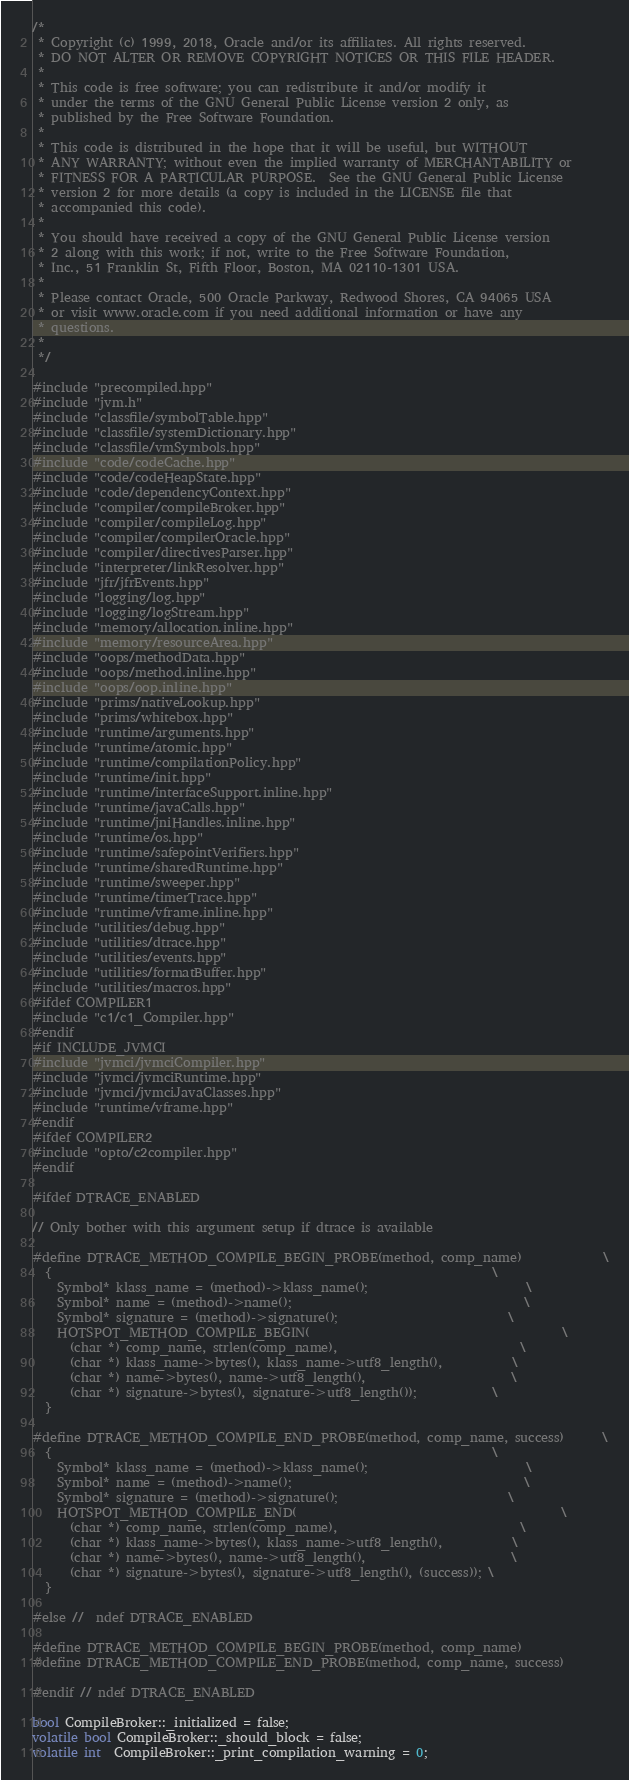Convert code to text. <code><loc_0><loc_0><loc_500><loc_500><_C++_>/*
 * Copyright (c) 1999, 2018, Oracle and/or its affiliates. All rights reserved.
 * DO NOT ALTER OR REMOVE COPYRIGHT NOTICES OR THIS FILE HEADER.
 *
 * This code is free software; you can redistribute it and/or modify it
 * under the terms of the GNU General Public License version 2 only, as
 * published by the Free Software Foundation.
 *
 * This code is distributed in the hope that it will be useful, but WITHOUT
 * ANY WARRANTY; without even the implied warranty of MERCHANTABILITY or
 * FITNESS FOR A PARTICULAR PURPOSE.  See the GNU General Public License
 * version 2 for more details (a copy is included in the LICENSE file that
 * accompanied this code).
 *
 * You should have received a copy of the GNU General Public License version
 * 2 along with this work; if not, write to the Free Software Foundation,
 * Inc., 51 Franklin St, Fifth Floor, Boston, MA 02110-1301 USA.
 *
 * Please contact Oracle, 500 Oracle Parkway, Redwood Shores, CA 94065 USA
 * or visit www.oracle.com if you need additional information or have any
 * questions.
 *
 */

#include "precompiled.hpp"
#include "jvm.h"
#include "classfile/symbolTable.hpp"
#include "classfile/systemDictionary.hpp"
#include "classfile/vmSymbols.hpp"
#include "code/codeCache.hpp"
#include "code/codeHeapState.hpp"
#include "code/dependencyContext.hpp"
#include "compiler/compileBroker.hpp"
#include "compiler/compileLog.hpp"
#include "compiler/compilerOracle.hpp"
#include "compiler/directivesParser.hpp"
#include "interpreter/linkResolver.hpp"
#include "jfr/jfrEvents.hpp"
#include "logging/log.hpp"
#include "logging/logStream.hpp"
#include "memory/allocation.inline.hpp"
#include "memory/resourceArea.hpp"
#include "oops/methodData.hpp"
#include "oops/method.inline.hpp"
#include "oops/oop.inline.hpp"
#include "prims/nativeLookup.hpp"
#include "prims/whitebox.hpp"
#include "runtime/arguments.hpp"
#include "runtime/atomic.hpp"
#include "runtime/compilationPolicy.hpp"
#include "runtime/init.hpp"
#include "runtime/interfaceSupport.inline.hpp"
#include "runtime/javaCalls.hpp"
#include "runtime/jniHandles.inline.hpp"
#include "runtime/os.hpp"
#include "runtime/safepointVerifiers.hpp"
#include "runtime/sharedRuntime.hpp"
#include "runtime/sweeper.hpp"
#include "runtime/timerTrace.hpp"
#include "runtime/vframe.inline.hpp"
#include "utilities/debug.hpp"
#include "utilities/dtrace.hpp"
#include "utilities/events.hpp"
#include "utilities/formatBuffer.hpp"
#include "utilities/macros.hpp"
#ifdef COMPILER1
#include "c1/c1_Compiler.hpp"
#endif
#if INCLUDE_JVMCI
#include "jvmci/jvmciCompiler.hpp"
#include "jvmci/jvmciRuntime.hpp"
#include "jvmci/jvmciJavaClasses.hpp"
#include "runtime/vframe.hpp"
#endif
#ifdef COMPILER2
#include "opto/c2compiler.hpp"
#endif

#ifdef DTRACE_ENABLED

// Only bother with this argument setup if dtrace is available

#define DTRACE_METHOD_COMPILE_BEGIN_PROBE(method, comp_name)             \
  {                                                                      \
    Symbol* klass_name = (method)->klass_name();                         \
    Symbol* name = (method)->name();                                     \
    Symbol* signature = (method)->signature();                           \
    HOTSPOT_METHOD_COMPILE_BEGIN(                                        \
      (char *) comp_name, strlen(comp_name),                             \
      (char *) klass_name->bytes(), klass_name->utf8_length(),           \
      (char *) name->bytes(), name->utf8_length(),                       \
      (char *) signature->bytes(), signature->utf8_length());            \
  }

#define DTRACE_METHOD_COMPILE_END_PROBE(method, comp_name, success)      \
  {                                                                      \
    Symbol* klass_name = (method)->klass_name();                         \
    Symbol* name = (method)->name();                                     \
    Symbol* signature = (method)->signature();                           \
    HOTSPOT_METHOD_COMPILE_END(                                          \
      (char *) comp_name, strlen(comp_name),                             \
      (char *) klass_name->bytes(), klass_name->utf8_length(),           \
      (char *) name->bytes(), name->utf8_length(),                       \
      (char *) signature->bytes(), signature->utf8_length(), (success)); \
  }

#else //  ndef DTRACE_ENABLED

#define DTRACE_METHOD_COMPILE_BEGIN_PROBE(method, comp_name)
#define DTRACE_METHOD_COMPILE_END_PROBE(method, comp_name, success)

#endif // ndef DTRACE_ENABLED

bool CompileBroker::_initialized = false;
volatile bool CompileBroker::_should_block = false;
volatile int  CompileBroker::_print_compilation_warning = 0;</code> 